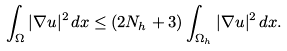<formula> <loc_0><loc_0><loc_500><loc_500>\int _ { \Omega } | \nabla u | ^ { 2 } \, d x \leq ( 2 N _ { h } + 3 ) \int _ { \Omega _ { h } } | \nabla u | ^ { 2 } \, d x .</formula> 